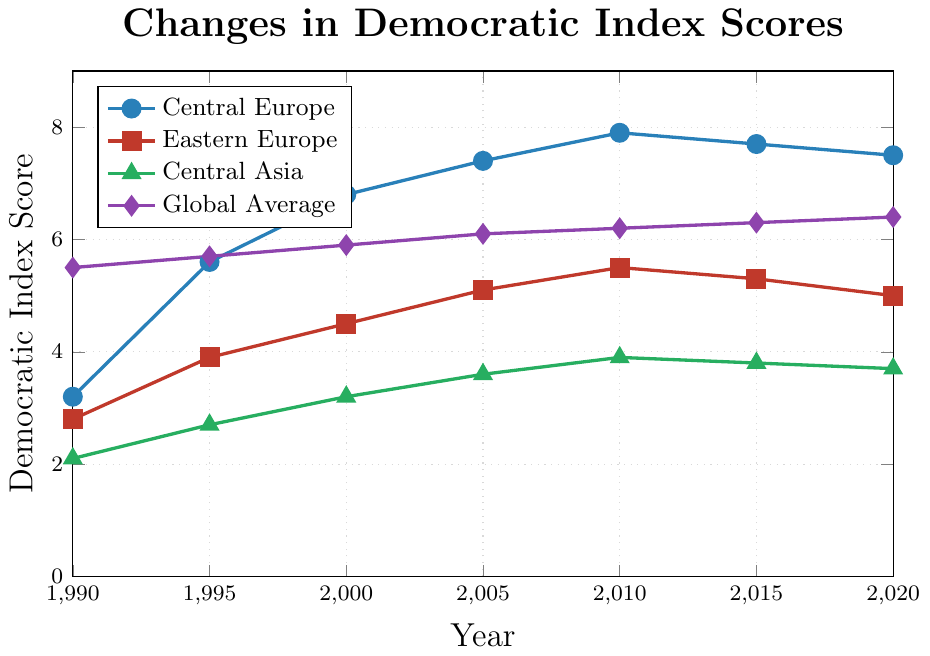What is the trend in the democratic index score for Central Europe from 1990 to 2020? The democratic index score for Central Europe shows a general upward trend from 1990 to 2010, with small declines after 2010. In 1990, the score was 3.2, it peaked at 7.9 in 2010, and slightly decreased to 7.5 in 2020.
Answer: Upward trend with slight declines after 2010 How does the democratic index score of Central Asia in 2020 compare to the global average in the same year? The democratic index score for Central Asia in 2020 is 3.7, while the global average is 6.4. Comparing these, Central Asia's score is significantly lower.
Answer: Central Asia's score is significantly lower Which region had the highest democratic index score in 2005? In 2005, Central Europe had the highest democratic index score of 7.4, which is higher compared to Eastern Europe's 5.1, Central Asia's 3.6, and the global average of 6.1.
Answer: Central Europe What is the difference in the democratic index score for Eastern Europe between 1990 and 2020? The democratic index score for Eastern Europe in 1990 was 2.8 and in 2020 it was 5.0. The difference is calculated as 5.0 - 2.8, which equals 2.2.
Answer: 2.2 Which region shows the least improvement in democratic index scores from 1990 to 2020? Central Asia shows the least improvement in democratic index scores, going from 2.1 in 1990 to 3.7 in 2020, which is an increase of 1.6. Other regions have significantly higher improvements.
Answer: Central Asia In which year did Central Europe surpass the global average in democratic index scores? Central Europe's democratic index score surpassed the global average in 1995. By that year, Central Europe had a score of 5.6, whereas the global average was 5.7. This trend continued beyond 1995.
Answer: 1995 What is the average democratic index score of Eastern Europe from 1990 to 2020? The democratic index scores for Eastern Europe from 1990 to 2020 are 2.8, 3.9, 4.5, 5.1, 5.5, 5.3, and 5.0. Summing these values gives 32.1, and dividing by the number of years (7) results in an average score of approximately 4.59.
Answer: 4.59 By how much did Central Europe's democratic index score increase between 1990 and 2000? Central Europe's score increased from 3.2 in 1990 to 6.8 in 2000. The difference is 6.8 - 3.2, which equals 3.6.
Answer: 3.6 Which region had a stagnation or decrease in the democratic index score after 2010? Both Central Europe and Eastern Europe experienced stagnation or a slight decrease in their democratic index scores from 2010 to 2020. Central Europe decreased from 7.9 to 7.5, and Eastern Europe from 5.5 to 5.0.
Answer: Central Europe and Eastern Europe 